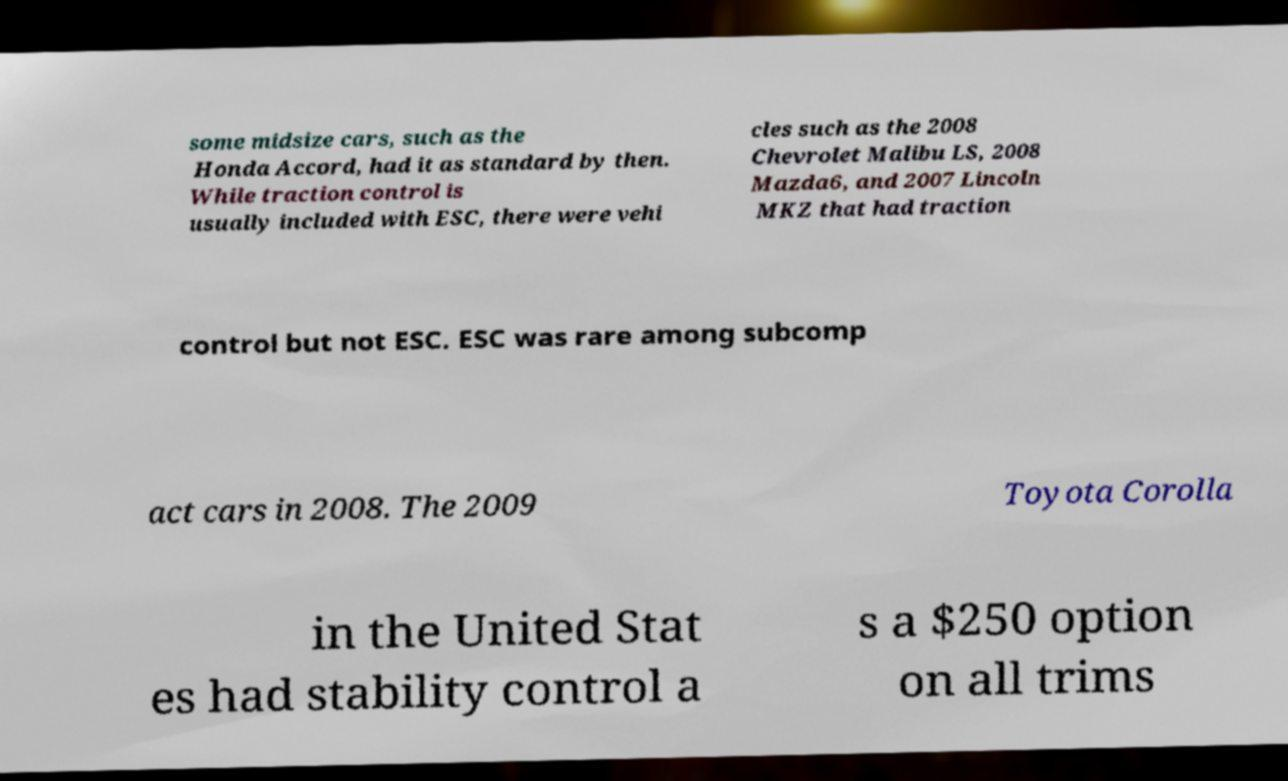Please identify and transcribe the text found in this image. some midsize cars, such as the Honda Accord, had it as standard by then. While traction control is usually included with ESC, there were vehi cles such as the 2008 Chevrolet Malibu LS, 2008 Mazda6, and 2007 Lincoln MKZ that had traction control but not ESC. ESC was rare among subcomp act cars in 2008. The 2009 Toyota Corolla in the United Stat es had stability control a s a $250 option on all trims 